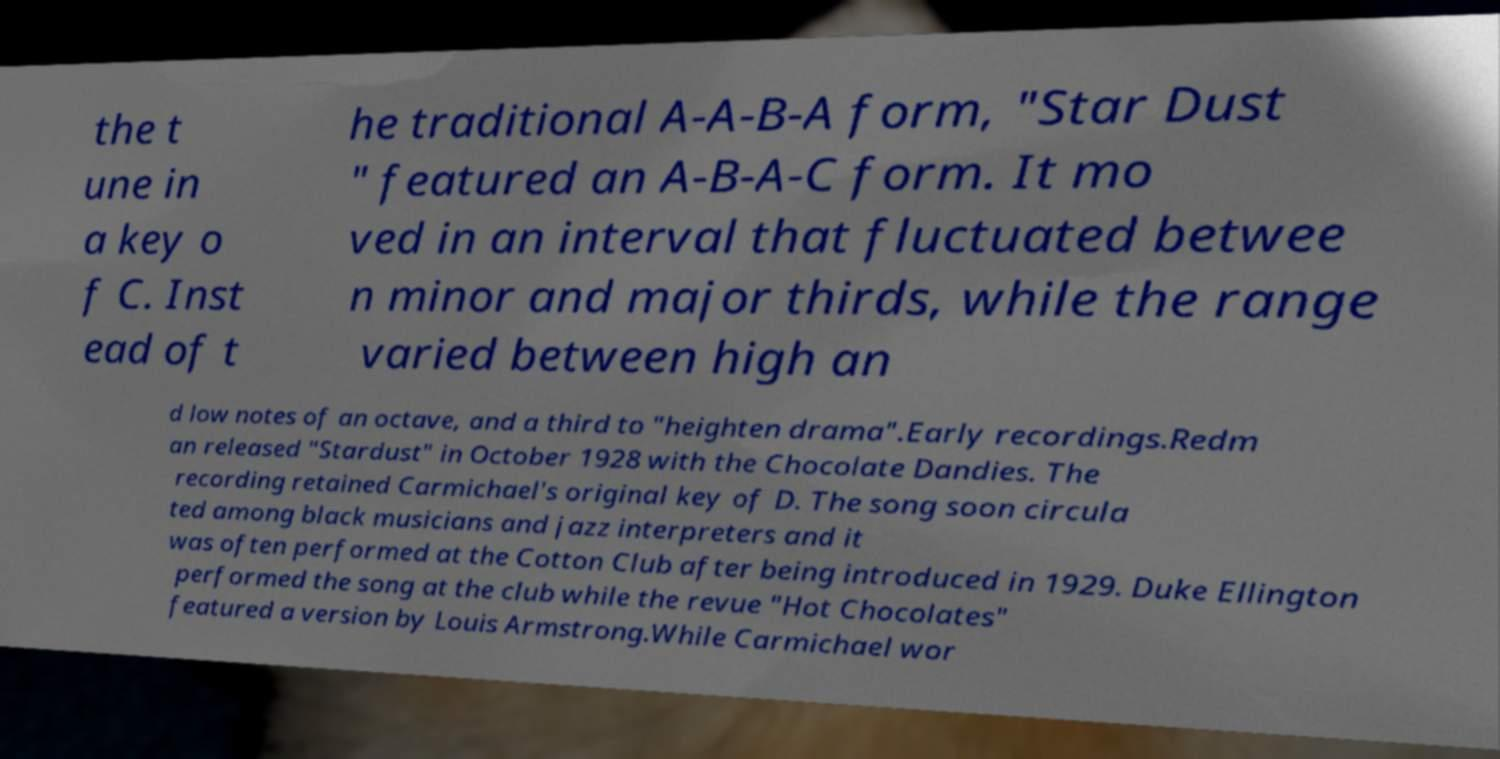Can you accurately transcribe the text from the provided image for me? the t une in a key o f C. Inst ead of t he traditional A-A-B-A form, "Star Dust " featured an A-B-A-C form. It mo ved in an interval that fluctuated betwee n minor and major thirds, while the range varied between high an d low notes of an octave, and a third to "heighten drama".Early recordings.Redm an released "Stardust" in October 1928 with the Chocolate Dandies. The recording retained Carmichael's original key of D. The song soon circula ted among black musicians and jazz interpreters and it was often performed at the Cotton Club after being introduced in 1929. Duke Ellington performed the song at the club while the revue "Hot Chocolates" featured a version by Louis Armstrong.While Carmichael wor 